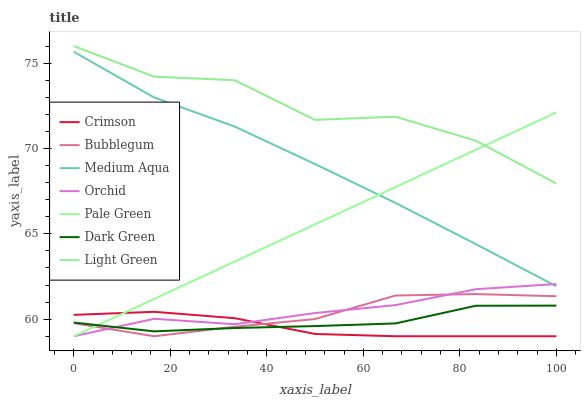Does Crimson have the minimum area under the curve?
Answer yes or no. Yes. Does Light Green have the maximum area under the curve?
Answer yes or no. Yes. Does Pale Green have the minimum area under the curve?
Answer yes or no. No. Does Pale Green have the maximum area under the curve?
Answer yes or no. No. Is Pale Green the smoothest?
Answer yes or no. Yes. Is Light Green the roughest?
Answer yes or no. Yes. Is Medium Aqua the smoothest?
Answer yes or no. No. Is Medium Aqua the roughest?
Answer yes or no. No. Does Bubblegum have the lowest value?
Answer yes or no. Yes. Does Medium Aqua have the lowest value?
Answer yes or no. No. Does Light Green have the highest value?
Answer yes or no. Yes. Does Pale Green have the highest value?
Answer yes or no. No. Is Orchid less than Light Green?
Answer yes or no. Yes. Is Light Green greater than Medium Aqua?
Answer yes or no. Yes. Does Pale Green intersect Light Green?
Answer yes or no. Yes. Is Pale Green less than Light Green?
Answer yes or no. No. Is Pale Green greater than Light Green?
Answer yes or no. No. Does Orchid intersect Light Green?
Answer yes or no. No. 